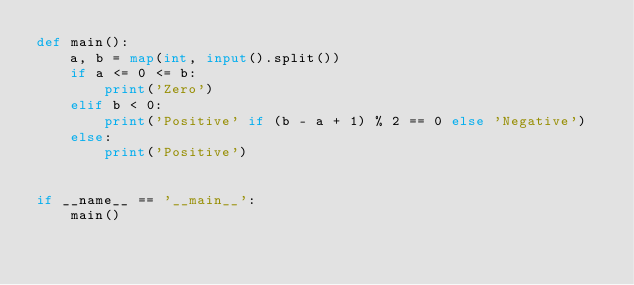Convert code to text. <code><loc_0><loc_0><loc_500><loc_500><_Python_>def main():
    a, b = map(int, input().split())
    if a <= 0 <= b:
        print('Zero')
    elif b < 0:
        print('Positive' if (b - a + 1) % 2 == 0 else 'Negative')
    else:
        print('Positive')


if __name__ == '__main__':
    main()
</code> 